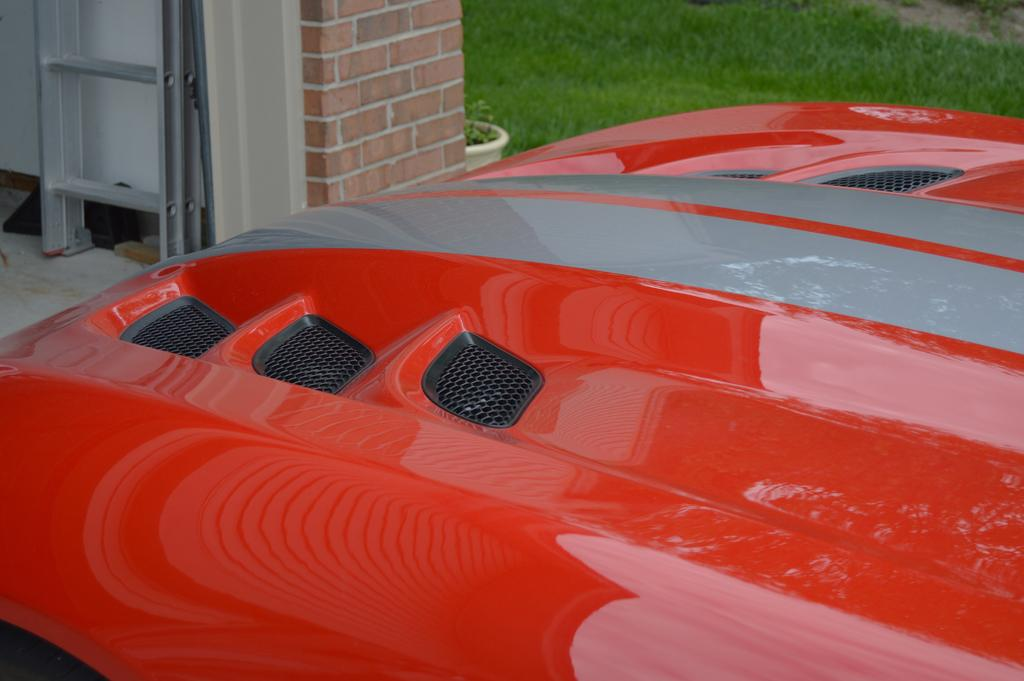What type of object is present in the image that can transport people or goods? There is a vehicle in the image that can transport people or goods. What is the tall, narrow object in the image that can be used for reaching higher places? There is a ladder in the image that can be used for reaching higher places. What type of plant is visible in the image? There is a house plant in the image. What type of structure is present in the image? There is a wall in the image. What type of natural environment is visible in the background of the image? There is grass visible in the background of the image. How many flowers are on the throne in the image? There is no throne present in the image, so it is not possible to determine the number of flowers on it. 